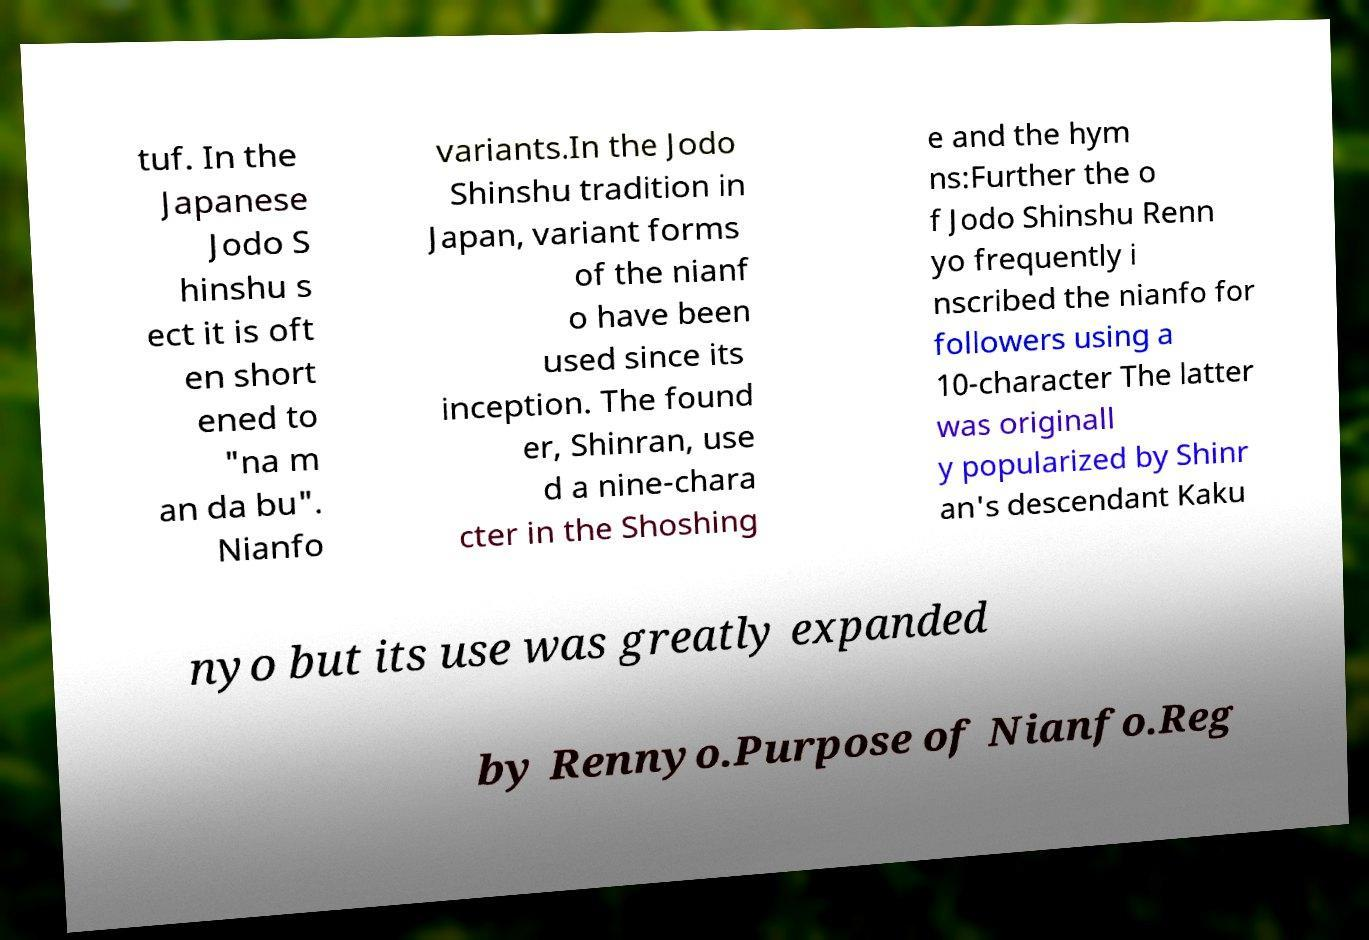Could you assist in decoding the text presented in this image and type it out clearly? tuf. In the Japanese Jodo S hinshu s ect it is oft en short ened to "na m an da bu". Nianfo variants.In the Jodo Shinshu tradition in Japan, variant forms of the nianf o have been used since its inception. The found er, Shinran, use d a nine-chara cter in the Shoshing e and the hym ns:Further the o f Jodo Shinshu Renn yo frequently i nscribed the nianfo for followers using a 10-character The latter was originall y popularized by Shinr an's descendant Kaku nyo but its use was greatly expanded by Rennyo.Purpose of Nianfo.Reg 